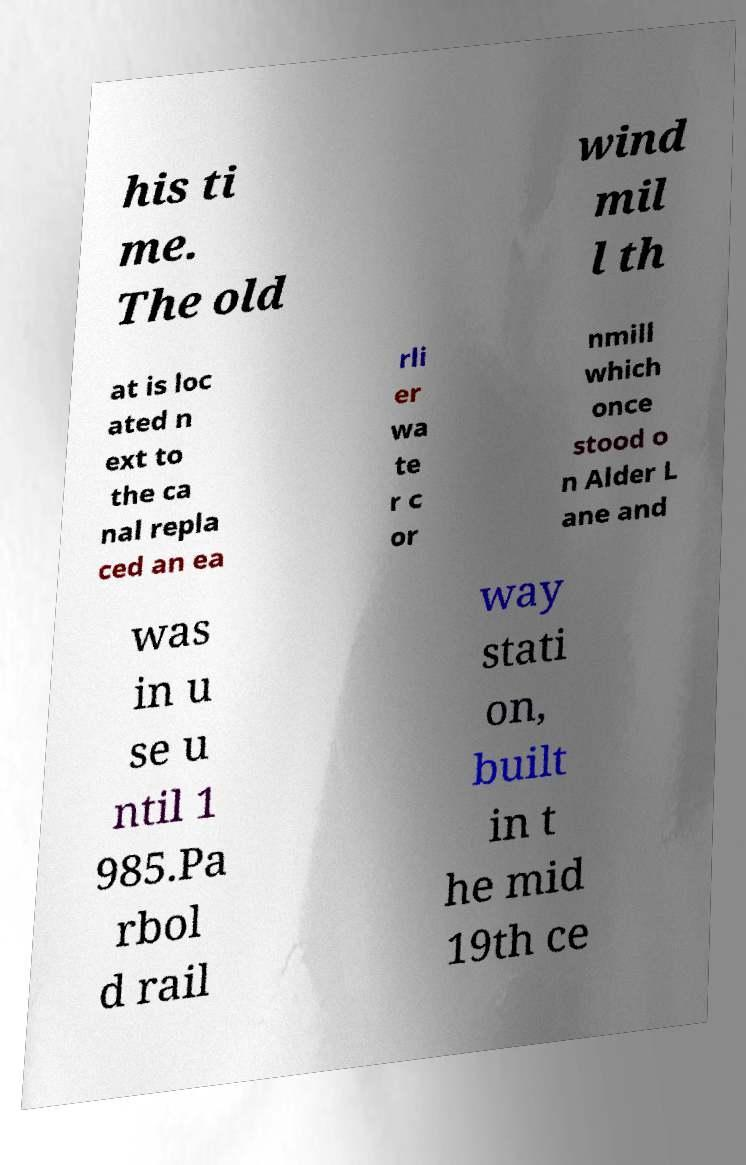Could you assist in decoding the text presented in this image and type it out clearly? his ti me. The old wind mil l th at is loc ated n ext to the ca nal repla ced an ea rli er wa te r c or nmill which once stood o n Alder L ane and was in u se u ntil 1 985.Pa rbol d rail way stati on, built in t he mid 19th ce 